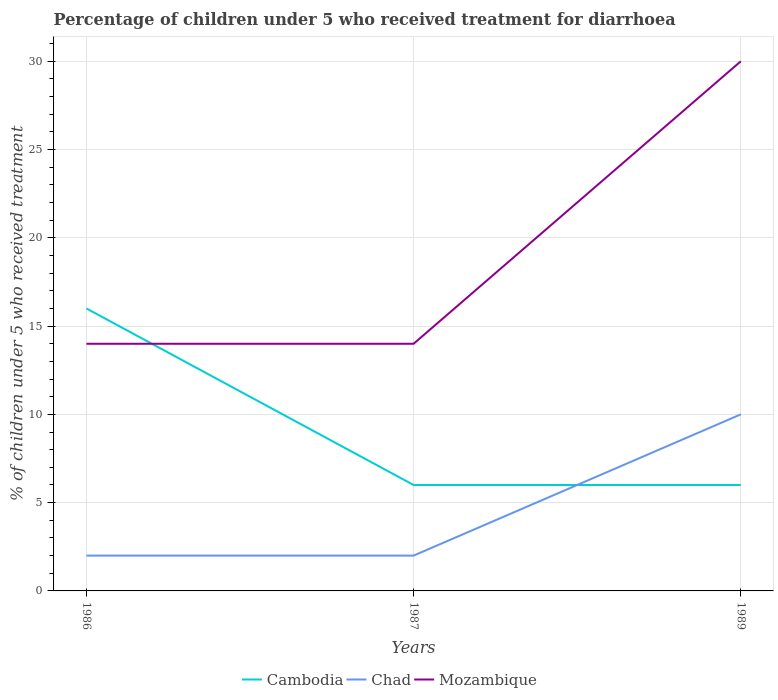How many different coloured lines are there?
Give a very brief answer. 3. What is the difference between the highest and the second highest percentage of children who received treatment for diarrhoea  in Mozambique?
Give a very brief answer. 16. What is the difference between the highest and the lowest percentage of children who received treatment for diarrhoea  in Mozambique?
Offer a very short reply. 1. Is the percentage of children who received treatment for diarrhoea  in Mozambique strictly greater than the percentage of children who received treatment for diarrhoea  in Cambodia over the years?
Your answer should be compact. No. How many years are there in the graph?
Your answer should be compact. 3. What is the difference between two consecutive major ticks on the Y-axis?
Give a very brief answer. 5. Are the values on the major ticks of Y-axis written in scientific E-notation?
Keep it short and to the point. No. Does the graph contain grids?
Make the answer very short. Yes. Where does the legend appear in the graph?
Give a very brief answer. Bottom center. What is the title of the graph?
Keep it short and to the point. Percentage of children under 5 who received treatment for diarrhoea. Does "Mozambique" appear as one of the legend labels in the graph?
Your answer should be compact. Yes. What is the label or title of the Y-axis?
Provide a short and direct response. % of children under 5 who received treatment. What is the % of children under 5 who received treatment of Cambodia in 1986?
Offer a very short reply. 16. What is the % of children under 5 who received treatment in Mozambique in 1986?
Give a very brief answer. 14. What is the % of children under 5 who received treatment in Cambodia in 1987?
Ensure brevity in your answer.  6. What is the % of children under 5 who received treatment of Chad in 1989?
Keep it short and to the point. 10. What is the % of children under 5 who received treatment in Mozambique in 1989?
Keep it short and to the point. 30. Across all years, what is the maximum % of children under 5 who received treatment in Cambodia?
Your response must be concise. 16. Across all years, what is the minimum % of children under 5 who received treatment in Chad?
Offer a very short reply. 2. Across all years, what is the minimum % of children under 5 who received treatment in Mozambique?
Make the answer very short. 14. What is the total % of children under 5 who received treatment of Mozambique in the graph?
Your response must be concise. 58. What is the difference between the % of children under 5 who received treatment in Cambodia in 1986 and that in 1989?
Provide a succinct answer. 10. What is the difference between the % of children under 5 who received treatment of Mozambique in 1986 and that in 1989?
Provide a succinct answer. -16. What is the difference between the % of children under 5 who received treatment in Cambodia in 1986 and the % of children under 5 who received treatment in Chad in 1987?
Provide a succinct answer. 14. What is the difference between the % of children under 5 who received treatment of Cambodia in 1986 and the % of children under 5 who received treatment of Mozambique in 1987?
Ensure brevity in your answer.  2. What is the difference between the % of children under 5 who received treatment of Chad in 1986 and the % of children under 5 who received treatment of Mozambique in 1987?
Your answer should be very brief. -12. What is the difference between the % of children under 5 who received treatment of Cambodia in 1986 and the % of children under 5 who received treatment of Chad in 1989?
Provide a succinct answer. 6. What is the difference between the % of children under 5 who received treatment in Chad in 1986 and the % of children under 5 who received treatment in Mozambique in 1989?
Provide a short and direct response. -28. What is the difference between the % of children under 5 who received treatment of Chad in 1987 and the % of children under 5 who received treatment of Mozambique in 1989?
Offer a terse response. -28. What is the average % of children under 5 who received treatment of Cambodia per year?
Ensure brevity in your answer.  9.33. What is the average % of children under 5 who received treatment in Chad per year?
Give a very brief answer. 4.67. What is the average % of children under 5 who received treatment of Mozambique per year?
Your response must be concise. 19.33. In the year 1986, what is the difference between the % of children under 5 who received treatment of Cambodia and % of children under 5 who received treatment of Chad?
Make the answer very short. 14. In the year 1986, what is the difference between the % of children under 5 who received treatment in Chad and % of children under 5 who received treatment in Mozambique?
Make the answer very short. -12. In the year 1987, what is the difference between the % of children under 5 who received treatment of Cambodia and % of children under 5 who received treatment of Chad?
Provide a succinct answer. 4. In the year 1989, what is the difference between the % of children under 5 who received treatment of Chad and % of children under 5 who received treatment of Mozambique?
Your response must be concise. -20. What is the ratio of the % of children under 5 who received treatment of Cambodia in 1986 to that in 1987?
Provide a short and direct response. 2.67. What is the ratio of the % of children under 5 who received treatment in Mozambique in 1986 to that in 1987?
Ensure brevity in your answer.  1. What is the ratio of the % of children under 5 who received treatment of Cambodia in 1986 to that in 1989?
Your answer should be very brief. 2.67. What is the ratio of the % of children under 5 who received treatment in Mozambique in 1986 to that in 1989?
Provide a succinct answer. 0.47. What is the ratio of the % of children under 5 who received treatment of Cambodia in 1987 to that in 1989?
Keep it short and to the point. 1. What is the ratio of the % of children under 5 who received treatment in Chad in 1987 to that in 1989?
Your response must be concise. 0.2. What is the ratio of the % of children under 5 who received treatment of Mozambique in 1987 to that in 1989?
Your answer should be compact. 0.47. What is the difference between the highest and the second highest % of children under 5 who received treatment of Cambodia?
Your answer should be very brief. 10. What is the difference between the highest and the lowest % of children under 5 who received treatment in Chad?
Your response must be concise. 8. 